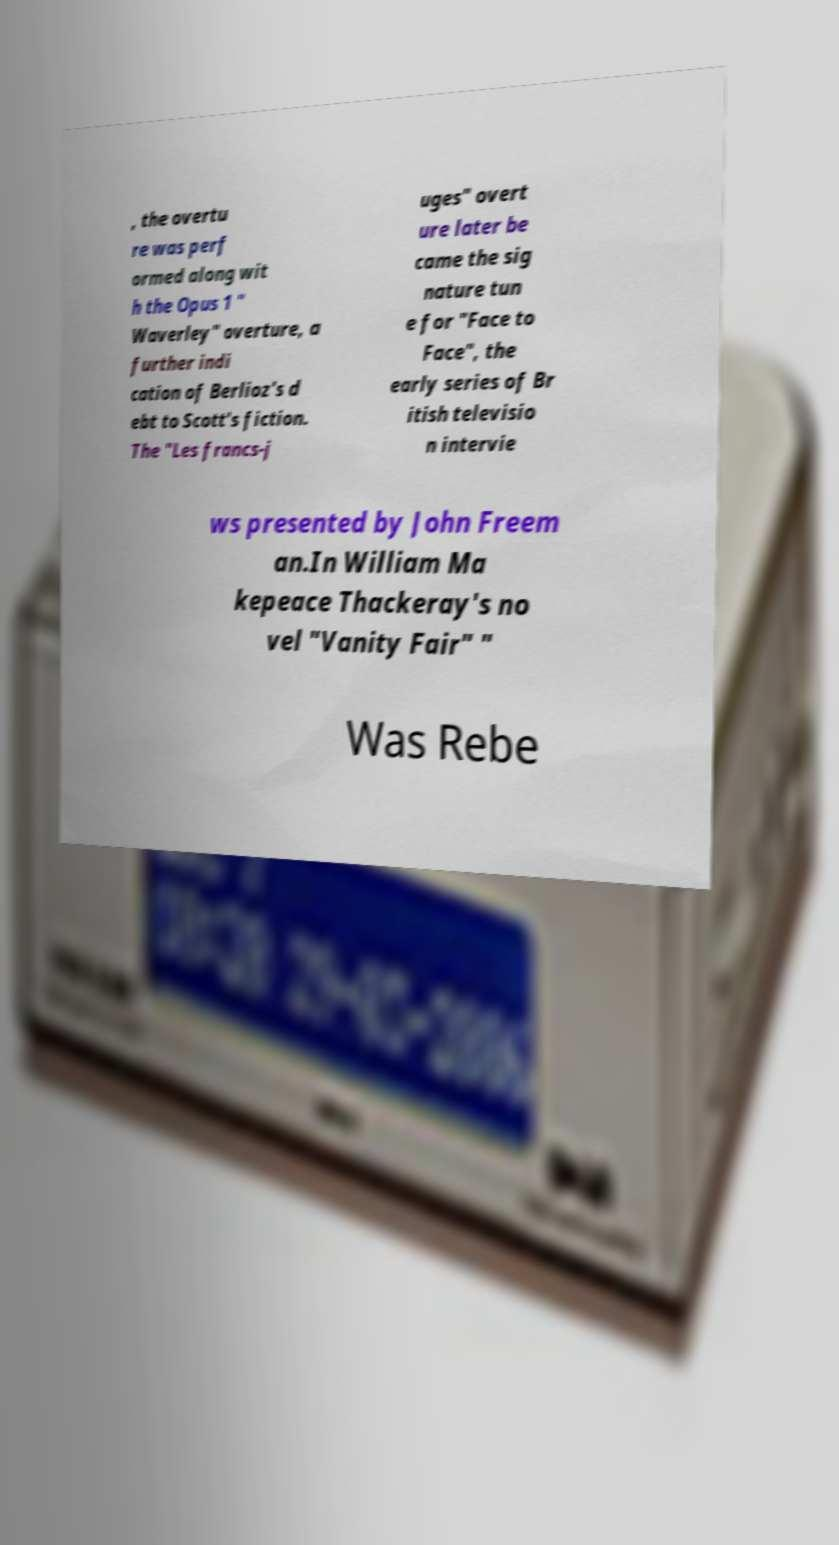Could you assist in decoding the text presented in this image and type it out clearly? , the overtu re was perf ormed along wit h the Opus 1 " Waverley" overture, a further indi cation of Berlioz's d ebt to Scott's fiction. The "Les francs-j uges" overt ure later be came the sig nature tun e for "Face to Face", the early series of Br itish televisio n intervie ws presented by John Freem an.In William Ma kepeace Thackeray's no vel "Vanity Fair" " Was Rebe 